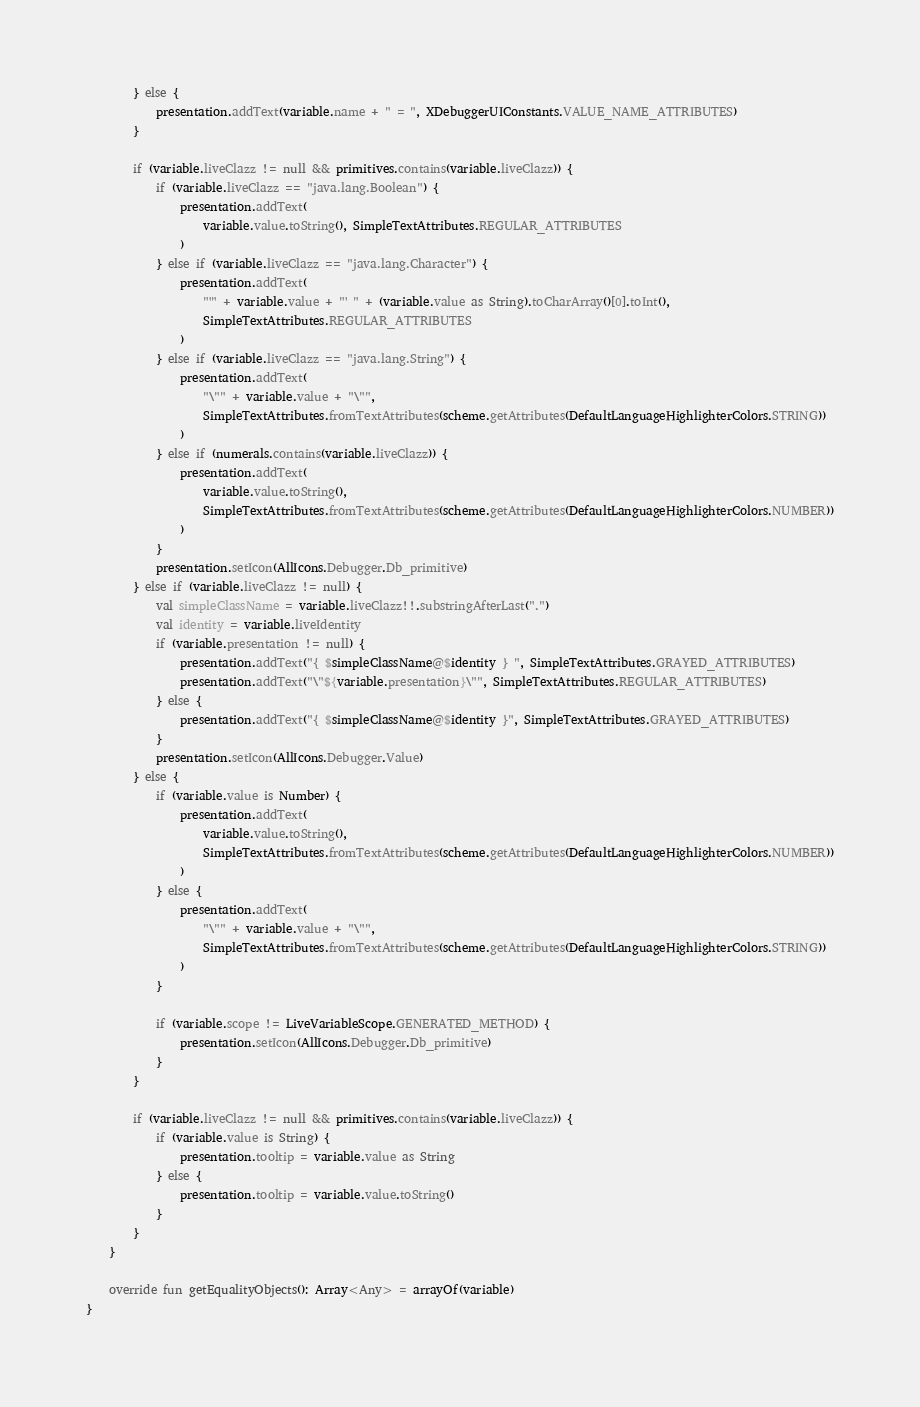Convert code to text. <code><loc_0><loc_0><loc_500><loc_500><_Kotlin_>        } else {
            presentation.addText(variable.name + " = ", XDebuggerUIConstants.VALUE_NAME_ATTRIBUTES)
        }

        if (variable.liveClazz != null && primitives.contains(variable.liveClazz)) {
            if (variable.liveClazz == "java.lang.Boolean") {
                presentation.addText(
                    variable.value.toString(), SimpleTextAttributes.REGULAR_ATTRIBUTES
                )
            } else if (variable.liveClazz == "java.lang.Character") {
                presentation.addText(
                    "'" + variable.value + "' " + (variable.value as String).toCharArray()[0].toInt(),
                    SimpleTextAttributes.REGULAR_ATTRIBUTES
                )
            } else if (variable.liveClazz == "java.lang.String") {
                presentation.addText(
                    "\"" + variable.value + "\"",
                    SimpleTextAttributes.fromTextAttributes(scheme.getAttributes(DefaultLanguageHighlighterColors.STRING))
                )
            } else if (numerals.contains(variable.liveClazz)) {
                presentation.addText(
                    variable.value.toString(),
                    SimpleTextAttributes.fromTextAttributes(scheme.getAttributes(DefaultLanguageHighlighterColors.NUMBER))
                )
            }
            presentation.setIcon(AllIcons.Debugger.Db_primitive)
        } else if (variable.liveClazz != null) {
            val simpleClassName = variable.liveClazz!!.substringAfterLast(".")
            val identity = variable.liveIdentity
            if (variable.presentation != null) {
                presentation.addText("{ $simpleClassName@$identity } ", SimpleTextAttributes.GRAYED_ATTRIBUTES)
                presentation.addText("\"${variable.presentation}\"", SimpleTextAttributes.REGULAR_ATTRIBUTES)
            } else {
                presentation.addText("{ $simpleClassName@$identity }", SimpleTextAttributes.GRAYED_ATTRIBUTES)
            }
            presentation.setIcon(AllIcons.Debugger.Value)
        } else {
            if (variable.value is Number) {
                presentation.addText(
                    variable.value.toString(),
                    SimpleTextAttributes.fromTextAttributes(scheme.getAttributes(DefaultLanguageHighlighterColors.NUMBER))
                )
            } else {
                presentation.addText(
                    "\"" + variable.value + "\"",
                    SimpleTextAttributes.fromTextAttributes(scheme.getAttributes(DefaultLanguageHighlighterColors.STRING))
                )
            }

            if (variable.scope != LiveVariableScope.GENERATED_METHOD) {
                presentation.setIcon(AllIcons.Debugger.Db_primitive)
            }
        }

        if (variable.liveClazz != null && primitives.contains(variable.liveClazz)) {
            if (variable.value is String) {
                presentation.tooltip = variable.value as String
            } else {
                presentation.tooltip = variable.value.toString()
            }
        }
    }

    override fun getEqualityObjects(): Array<Any> = arrayOf(variable)
}
</code> 